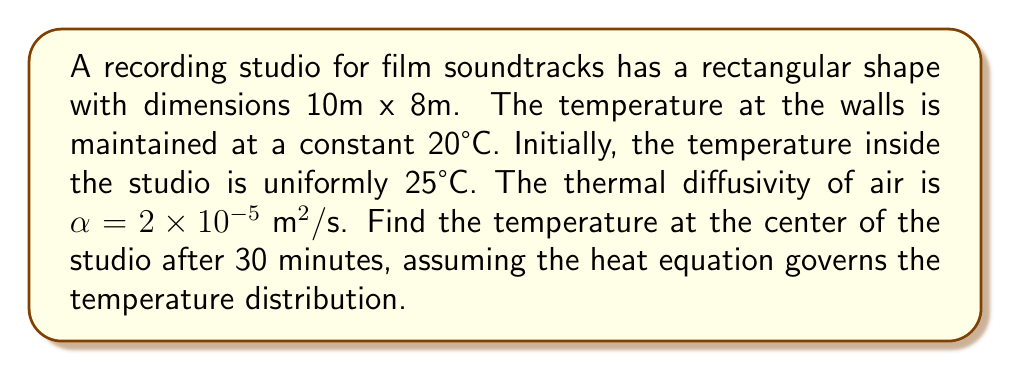Solve this math problem. To solve this problem, we'll use the 2D heat equation with the given initial and boundary conditions. The heat equation in 2D is:

$$\frac{\partial u}{\partial t} = \alpha \left(\frac{\partial^2 u}{\partial x^2} + \frac{\partial^2 u}{\partial y^2}\right)$$

where $u(x,y,t)$ is the temperature at position $(x,y)$ and time $t$.

Given:
- Domain: $0 \leq x \leq 10$, $0 \leq y \leq 8$
- Boundary conditions: $u(0,y,t) = u(10,y,t) = u(x,0,t) = u(x,8,t) = 20°C$
- Initial condition: $u(x,y,0) = 25°C$
- $\alpha = 2 \times 10^{-5} \text{ m}^2/\text{s}$
- Time: $t = 30 \text{ minutes} = 1800 \text{ seconds}$

The solution to this problem can be expressed as a Fourier series:

$$u(x,y,t) = 20 + \sum_{m=1}^{\infty}\sum_{n=1}^{\infty} A_{mn} \sin\left(\frac{m\pi x}{10}\right) \sin\left(\frac{n\pi y}{8}\right) e^{-\alpha t(\frac{m^2\pi^2}{100} + \frac{n^2\pi^2}{64})}$$

where

$$A_{mn} = \frac{16}{mn\pi^2} \int_0^{10} \int_0^8 (25-20) \sin\left(\frac{m\pi x}{10}\right) \sin\left(\frac{n\pi y}{8}\right) dx dy = \frac{400}{mn\pi^2}(1-(-1)^m)(1-(-1)^n)$$

The temperature at the center $(x=5, y=4)$ after 30 minutes is:

$$u(5,4,1800) = 20 + \sum_{m=1,3,5,...}^{\infty}\sum_{n=1,3,5,...}^{\infty} \frac{1600}{mn\pi^2} \sin\left(\frac{m\pi}{2}\right) \sin\left(\frac{n\pi}{2}\right) e^{-2 \times 10^{-5} \times 1800(\frac{m^2\pi^2}{100} + \frac{n^2\pi^2}{64})}$$

Calculating the first few terms of this series (e.g., up to $m=n=5$) gives us a good approximation of the temperature.
Answer: $20.28°C$ 